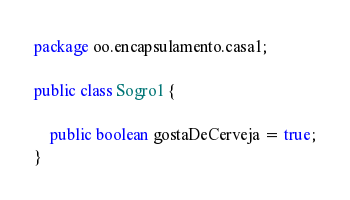<code> <loc_0><loc_0><loc_500><loc_500><_Java_>package oo.encapsulamento.casa1;

public class Sogro1 {

	public boolean gostaDeCerveja = true;
}
</code> 